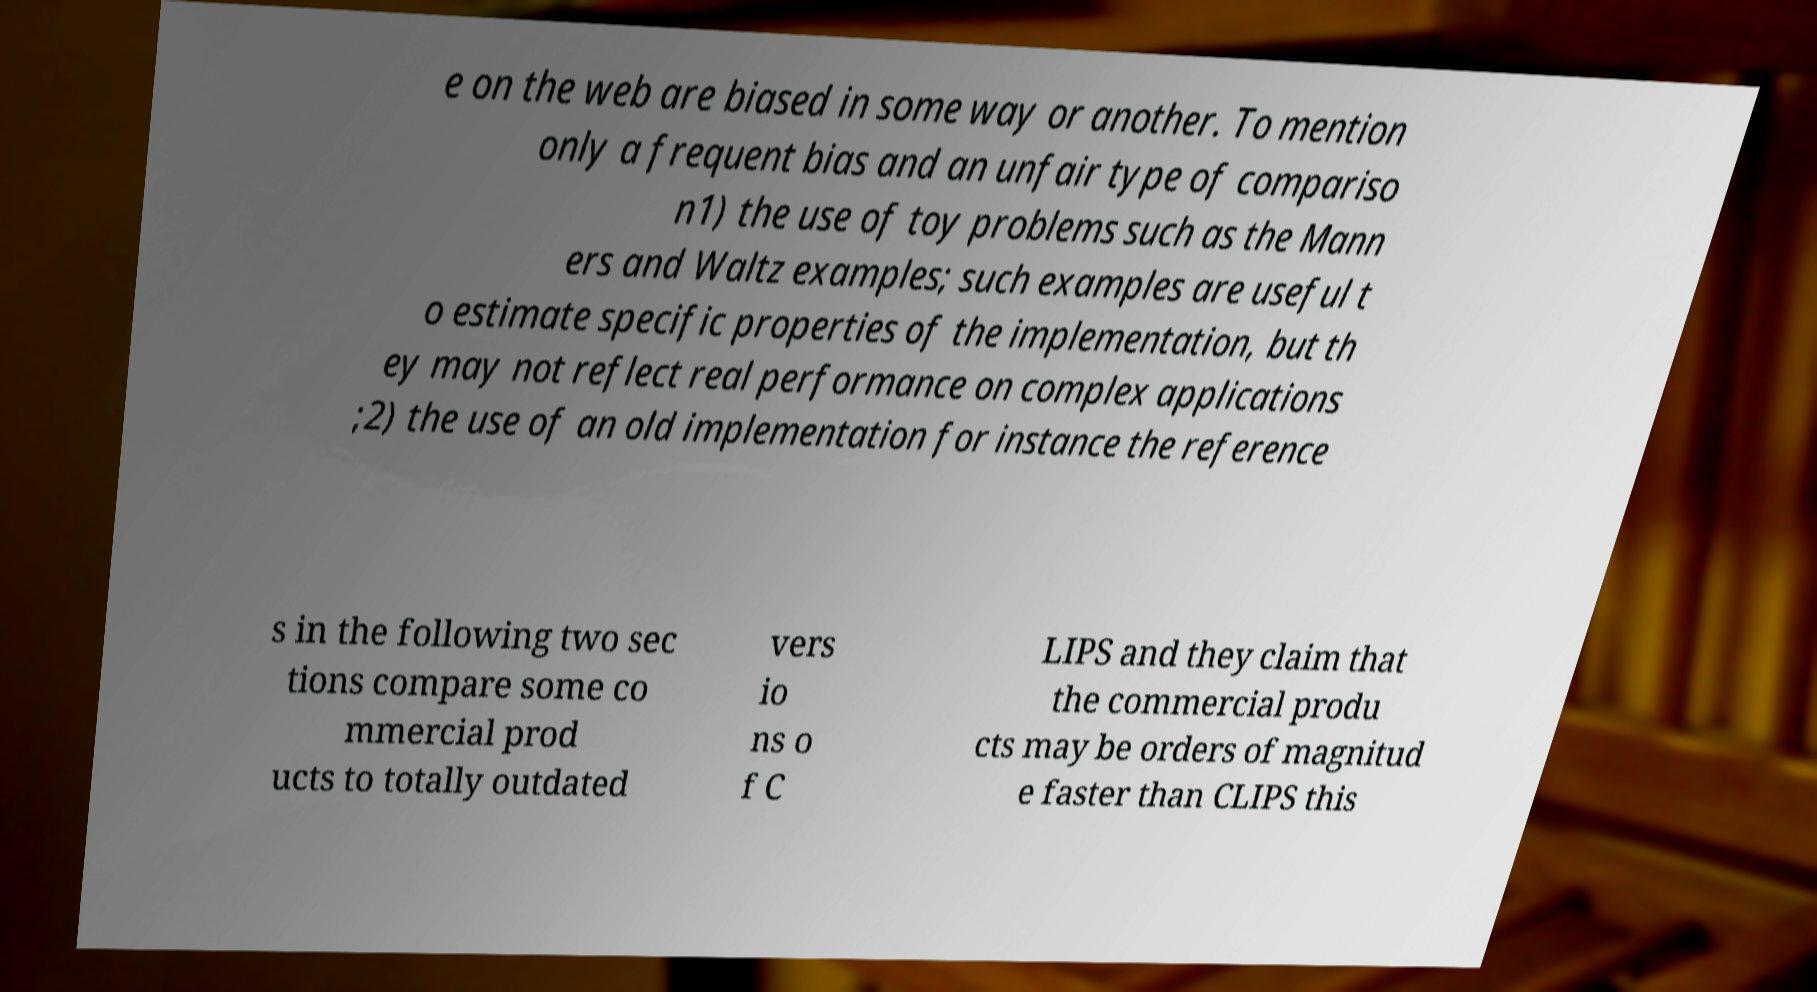Please identify and transcribe the text found in this image. e on the web are biased in some way or another. To mention only a frequent bias and an unfair type of compariso n1) the use of toy problems such as the Mann ers and Waltz examples; such examples are useful t o estimate specific properties of the implementation, but th ey may not reflect real performance on complex applications ;2) the use of an old implementation for instance the reference s in the following two sec tions compare some co mmercial prod ucts to totally outdated vers io ns o f C LIPS and they claim that the commercial produ cts may be orders of magnitud e faster than CLIPS this 